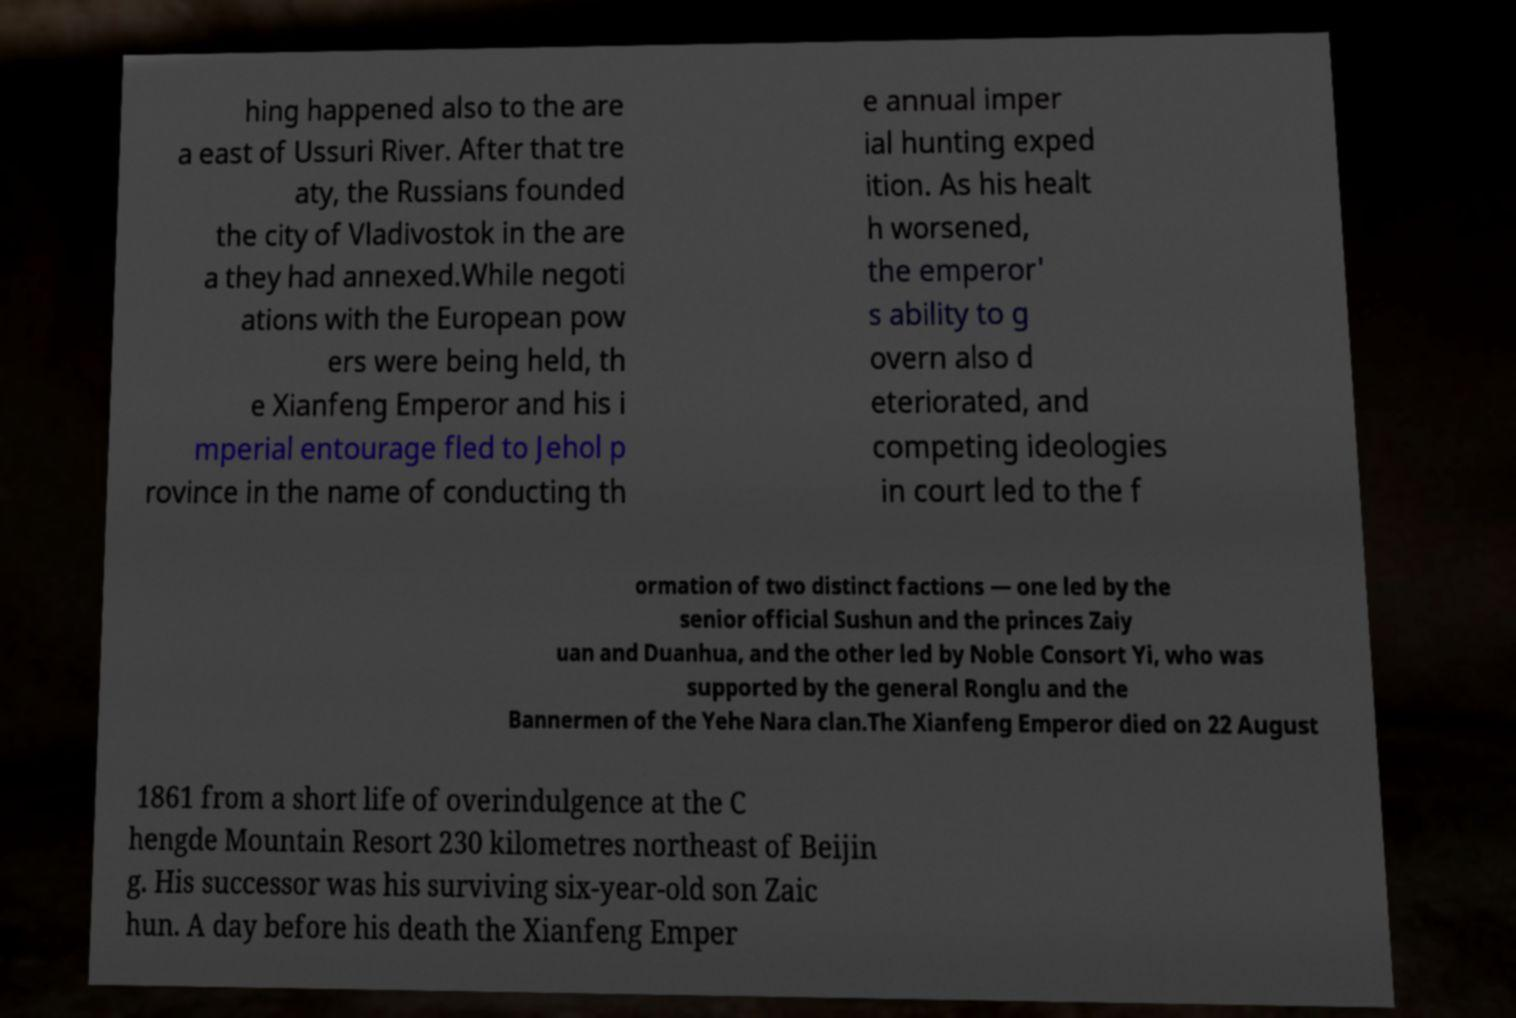What messages or text are displayed in this image? I need them in a readable, typed format. hing happened also to the are a east of Ussuri River. After that tre aty, the Russians founded the city of Vladivostok in the are a they had annexed.While negoti ations with the European pow ers were being held, th e Xianfeng Emperor and his i mperial entourage fled to Jehol p rovince in the name of conducting th e annual imper ial hunting exped ition. As his healt h worsened, the emperor' s ability to g overn also d eteriorated, and competing ideologies in court led to the f ormation of two distinct factions — one led by the senior official Sushun and the princes Zaiy uan and Duanhua, and the other led by Noble Consort Yi, who was supported by the general Ronglu and the Bannermen of the Yehe Nara clan.The Xianfeng Emperor died on 22 August 1861 from a short life of overindulgence at the C hengde Mountain Resort 230 kilometres northeast of Beijin g. His successor was his surviving six-year-old son Zaic hun. A day before his death the Xianfeng Emper 